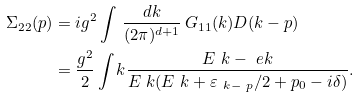Convert formula to latex. <formula><loc_0><loc_0><loc_500><loc_500>\Sigma _ { 2 2 } ( p ) & = i g ^ { 2 } \int \, \frac { d k } { ( 2 \pi ) ^ { d + 1 } } \, G _ { 1 1 } ( k ) D ( k - p ) \\ & = \frac { g ^ { 2 } } 2 \int _ { \ } k \frac { E _ { \ } k - \ e k } { E _ { \ } k ( E _ { \ } k + \varepsilon _ { \ k - \ p } / 2 + p _ { 0 } - i \delta ) } .</formula> 